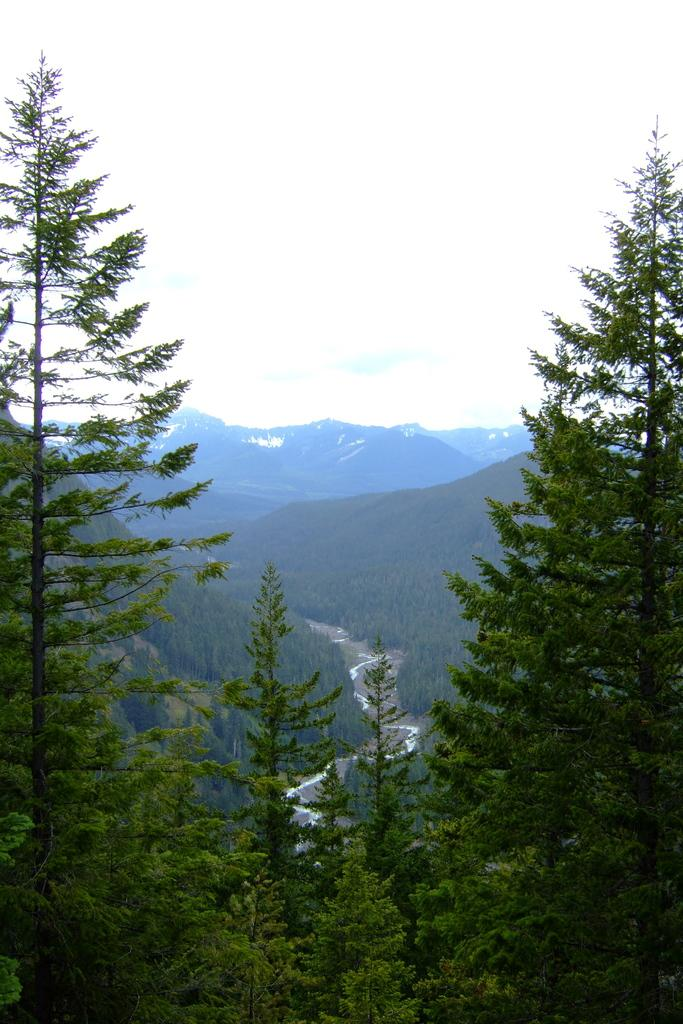What type of vegetation is present in the image? There are green color trees in the image. What geographical feature can be seen in the background? There are mountains in the image. What is visible at the top of the image? The sky is visible at the top of the image and is white in color. What holiday is being celebrated in the image? There is no indication of a holiday being celebrated in the image. What decision was made by the trees in the image? Trees do not make decisions, as they are inanimate objects. 